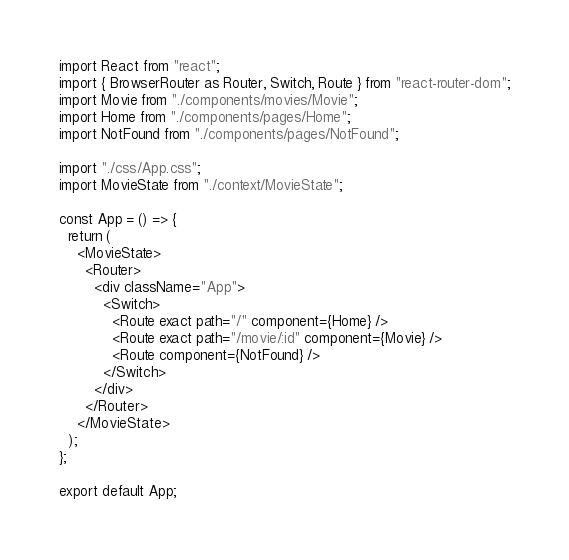<code> <loc_0><loc_0><loc_500><loc_500><_JavaScript_>import React from "react";
import { BrowserRouter as Router, Switch, Route } from "react-router-dom";
import Movie from "./components/movies/Movie";
import Home from "./components/pages/Home";
import NotFound from "./components/pages/NotFound";

import "./css/App.css";
import MovieState from "./context/MovieState";

const App = () => {
  return (
    <MovieState>
      <Router>
        <div className="App">
          <Switch>
            <Route exact path="/" component={Home} />
            <Route exact path="/movie/:id" component={Movie} />
            <Route component={NotFound} />
          </Switch>
        </div>
      </Router>
    </MovieState>
  );
};

export default App;
</code> 